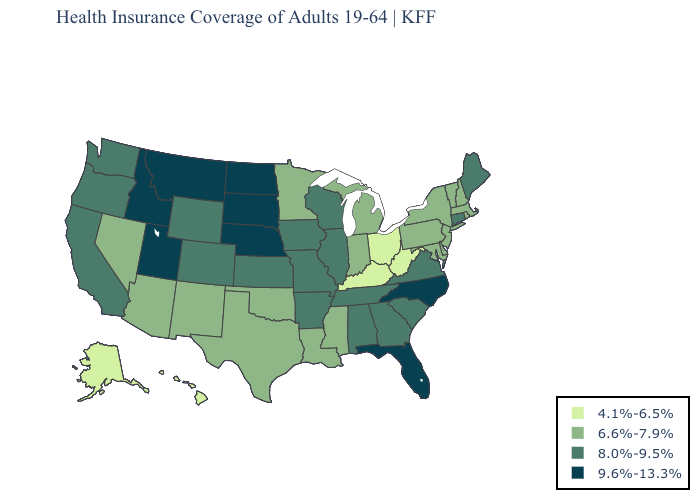Does Minnesota have the lowest value in the USA?
Answer briefly. No. Name the states that have a value in the range 4.1%-6.5%?
Write a very short answer. Alaska, Hawaii, Kentucky, Ohio, West Virginia. What is the lowest value in states that border Nevada?
Concise answer only. 6.6%-7.9%. What is the value of Vermont?
Short answer required. 6.6%-7.9%. What is the value of Iowa?
Be succinct. 8.0%-9.5%. Name the states that have a value in the range 9.6%-13.3%?
Short answer required. Florida, Idaho, Montana, Nebraska, North Carolina, North Dakota, South Dakota, Utah. Name the states that have a value in the range 8.0%-9.5%?
Short answer required. Alabama, Arkansas, California, Colorado, Connecticut, Georgia, Illinois, Iowa, Kansas, Maine, Missouri, Oregon, South Carolina, Tennessee, Virginia, Washington, Wisconsin, Wyoming. Does Michigan have the lowest value in the MidWest?
Write a very short answer. No. What is the value of Virginia?
Short answer required. 8.0%-9.5%. Name the states that have a value in the range 4.1%-6.5%?
Answer briefly. Alaska, Hawaii, Kentucky, Ohio, West Virginia. What is the value of Georgia?
Keep it brief. 8.0%-9.5%. What is the value of Texas?
Answer briefly. 6.6%-7.9%. 